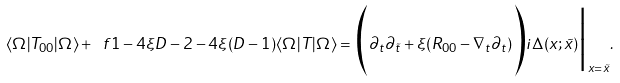<formula> <loc_0><loc_0><loc_500><loc_500>\langle \Omega | T _ { 0 0 } | \Omega \rangle + \ f { 1 - 4 \xi } { D - 2 - 4 \xi ( D - 1 ) } \langle \Omega | T | \Omega \rangle = \Big ( \partial _ { t } \partial _ { \tilde { t } } + \xi ( R _ { 0 0 } - \nabla _ { t } \partial _ { t } ) \Big ) i \Delta ( x ; \tilde { x } ) \Big | _ { x = \tilde { x } } .</formula> 